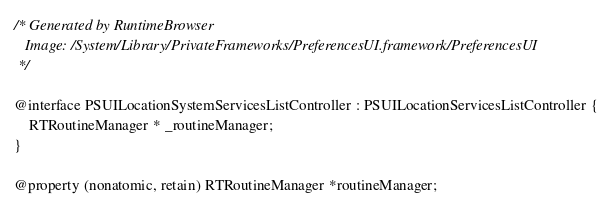<code> <loc_0><loc_0><loc_500><loc_500><_C_>/* Generated by RuntimeBrowser
   Image: /System/Library/PrivateFrameworks/PreferencesUI.framework/PreferencesUI
 */

@interface PSUILocationSystemServicesListController : PSUILocationServicesListController {
    RTRoutineManager * _routineManager;
}

@property (nonatomic, retain) RTRoutineManager *routineManager;
</code> 